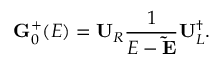Convert formula to latex. <formula><loc_0><loc_0><loc_500><loc_500>G _ { 0 } ^ { + } ( E ) = U _ { R } \frac { 1 } { E - \tilde { E } } U _ { L } ^ { \dagger } .</formula> 